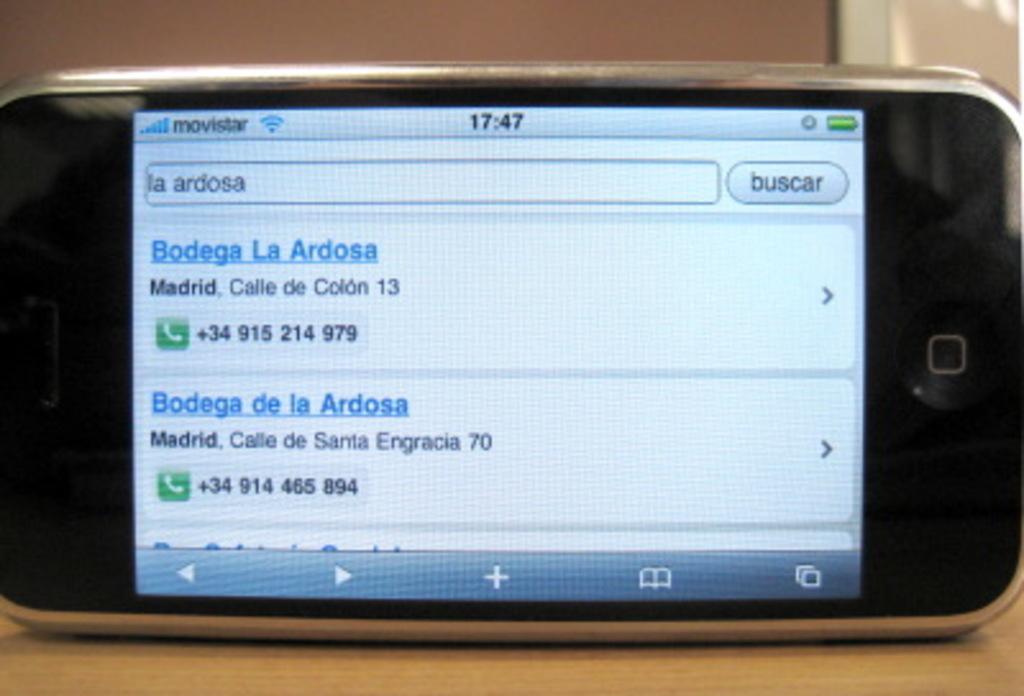What's the top phone number?
Make the answer very short. +34 915 214 979. What number is on the phone?
Provide a succinct answer. +34915214979. 